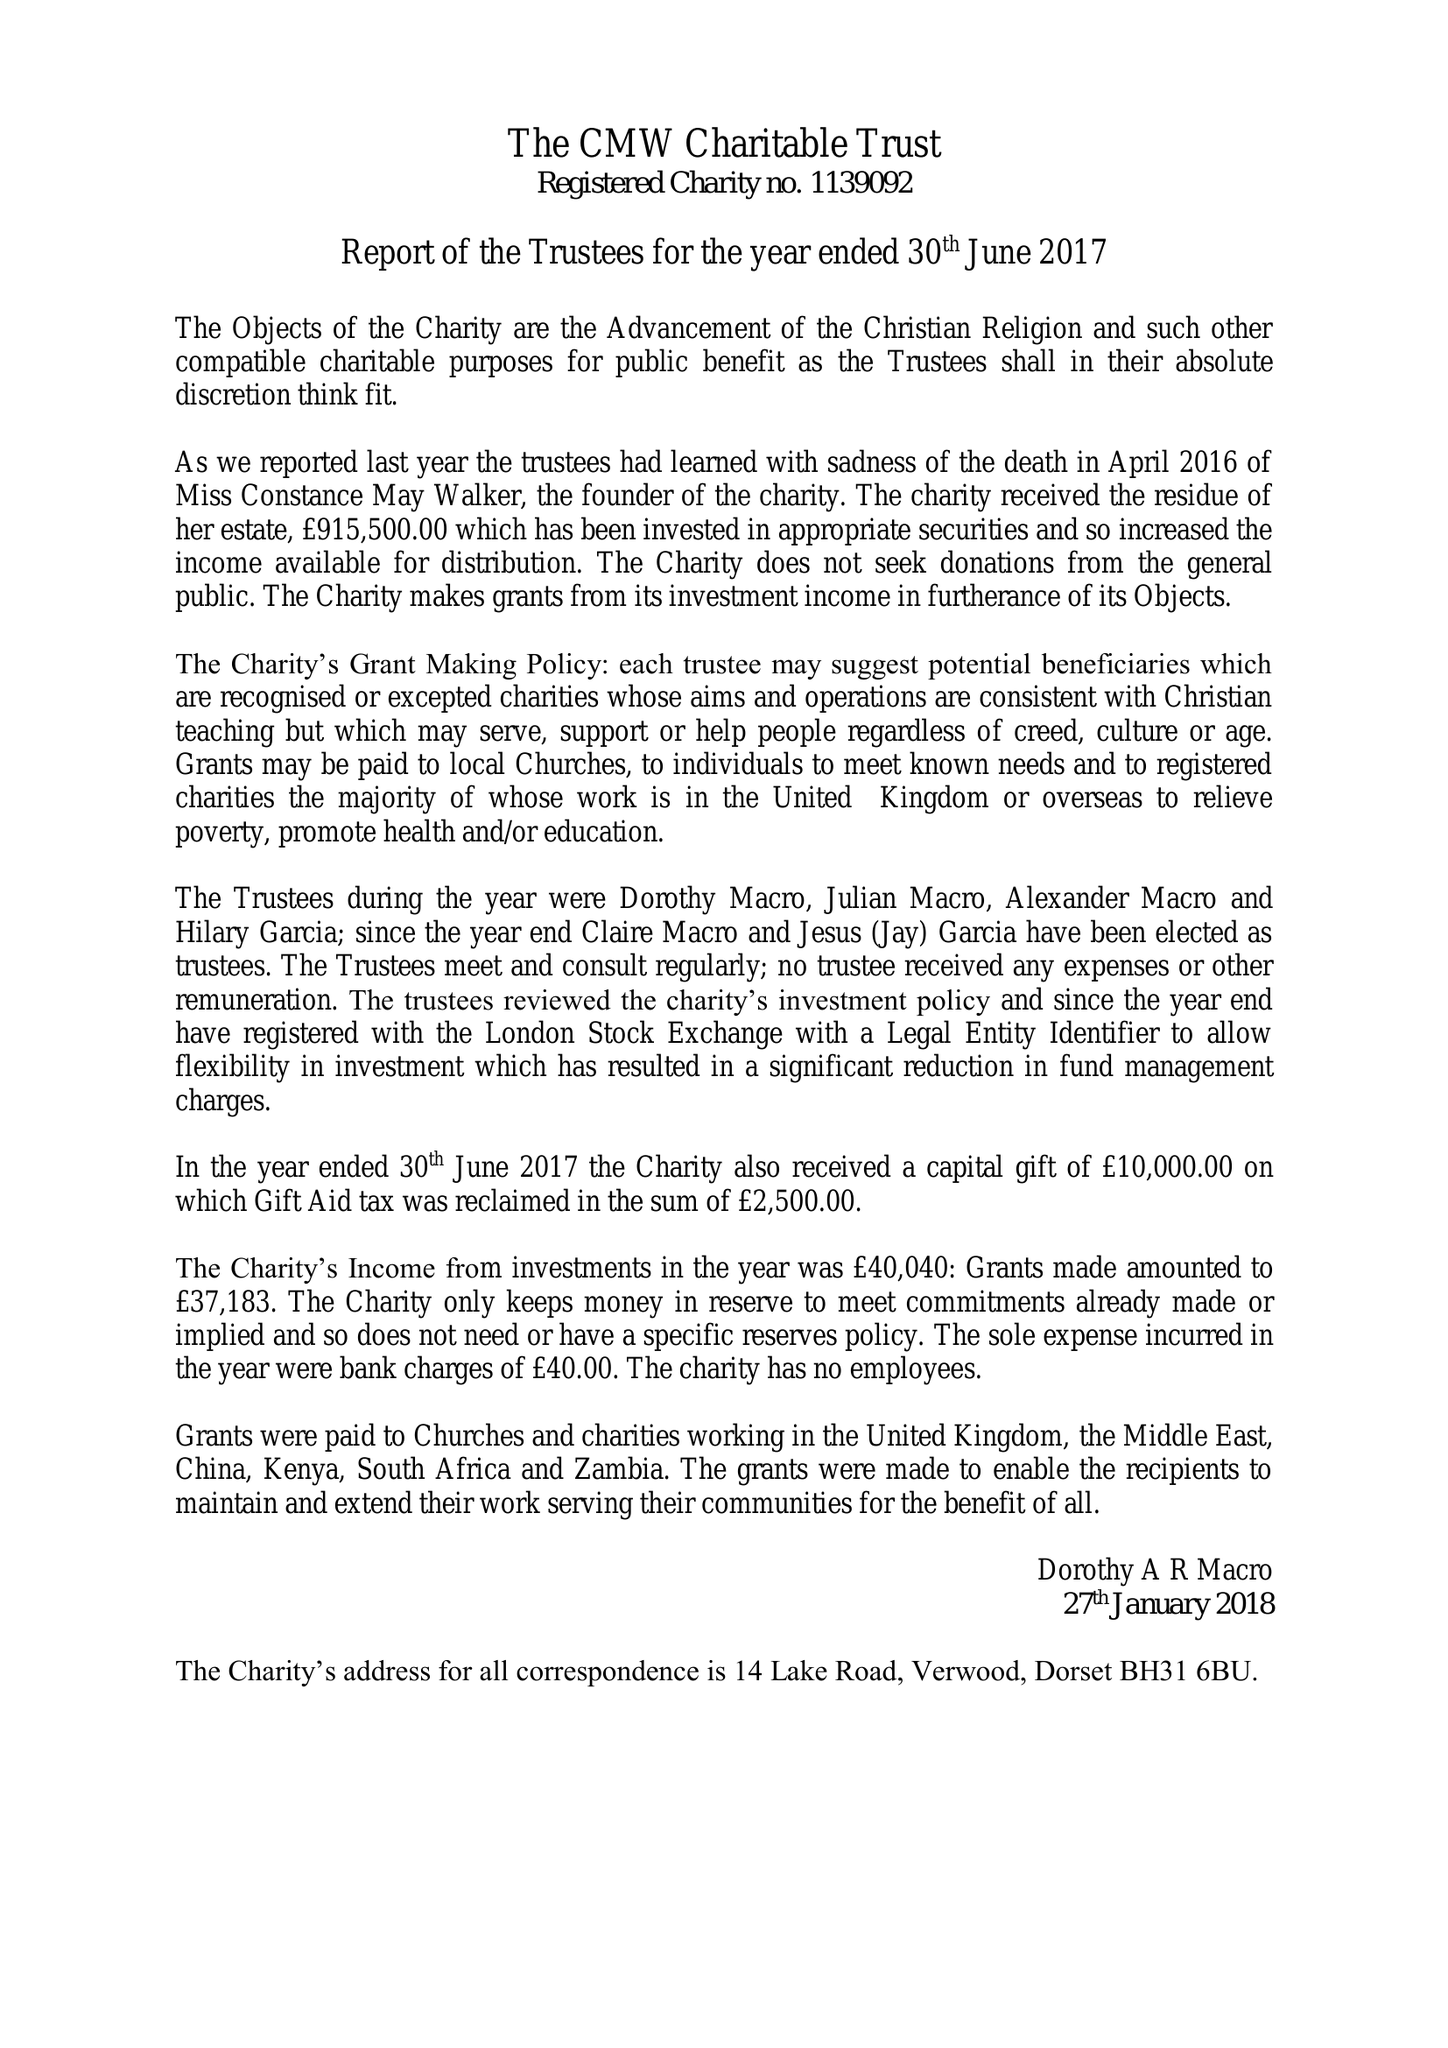What is the value for the report_date?
Answer the question using a single word or phrase. 2017-06-30 